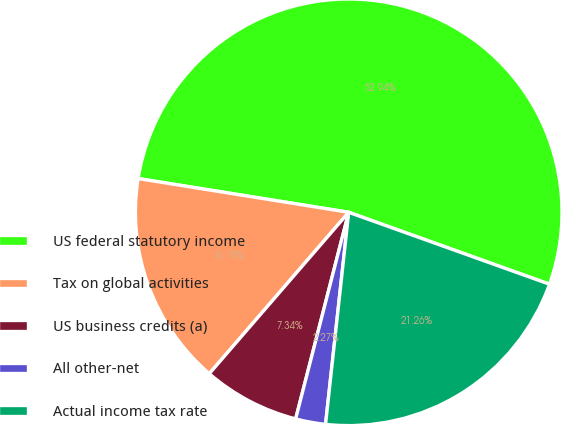Convert chart. <chart><loc_0><loc_0><loc_500><loc_500><pie_chart><fcel>US federal statutory income<fcel>Tax on global activities<fcel>US business credits (a)<fcel>All other-net<fcel>Actual income tax rate<nl><fcel>52.95%<fcel>16.19%<fcel>7.34%<fcel>2.27%<fcel>21.26%<nl></chart> 